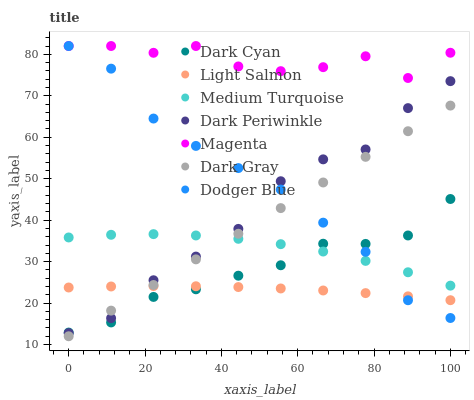Does Light Salmon have the minimum area under the curve?
Answer yes or no. Yes. Does Magenta have the maximum area under the curve?
Answer yes or no. Yes. Does Dark Gray have the minimum area under the curve?
Answer yes or no. No. Does Dark Gray have the maximum area under the curve?
Answer yes or no. No. Is Dark Gray the smoothest?
Answer yes or no. Yes. Is Magenta the roughest?
Answer yes or no. Yes. Is Dodger Blue the smoothest?
Answer yes or no. No. Is Dodger Blue the roughest?
Answer yes or no. No. Does Dark Gray have the lowest value?
Answer yes or no. Yes. Does Dodger Blue have the lowest value?
Answer yes or no. No. Does Magenta have the highest value?
Answer yes or no. Yes. Does Dark Gray have the highest value?
Answer yes or no. No. Is Light Salmon less than Magenta?
Answer yes or no. Yes. Is Magenta greater than Dark Gray?
Answer yes or no. Yes. Does Light Salmon intersect Dodger Blue?
Answer yes or no. Yes. Is Light Salmon less than Dodger Blue?
Answer yes or no. No. Is Light Salmon greater than Dodger Blue?
Answer yes or no. No. Does Light Salmon intersect Magenta?
Answer yes or no. No. 